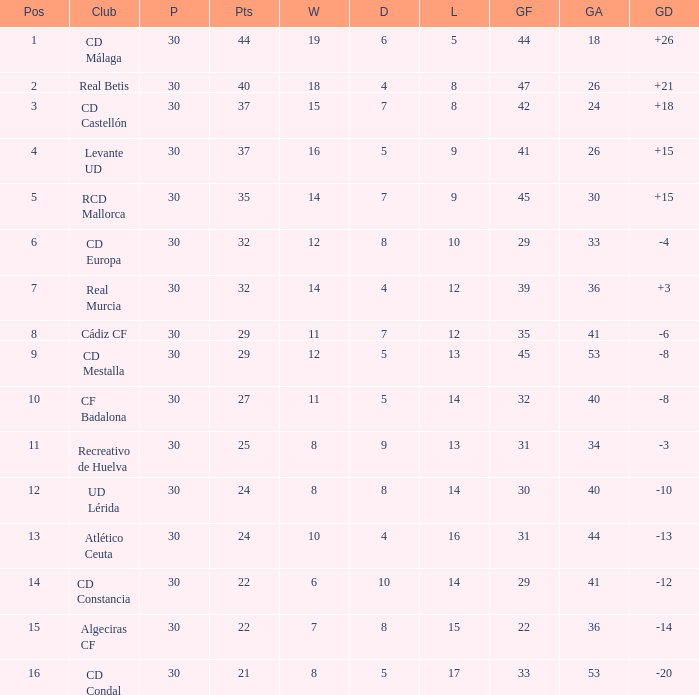What is the number of draws when played is smaller than 30? 0.0. 